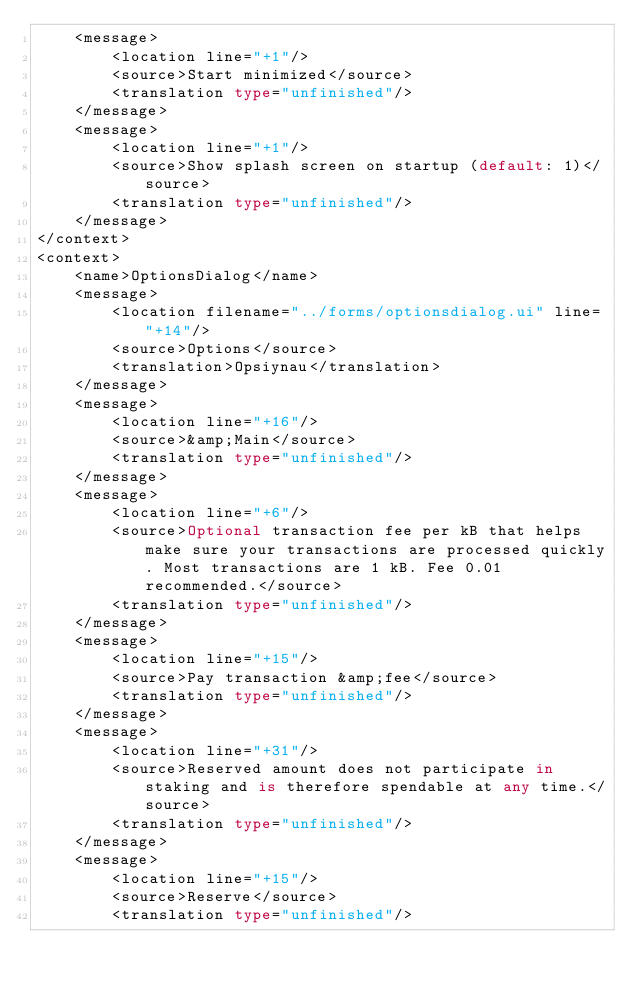Convert code to text. <code><loc_0><loc_0><loc_500><loc_500><_TypeScript_>    <message>
        <location line="+1"/>
        <source>Start minimized</source>
        <translation type="unfinished"/>
    </message>
    <message>
        <location line="+1"/>
        <source>Show splash screen on startup (default: 1)</source>
        <translation type="unfinished"/>
    </message>
</context>
<context>
    <name>OptionsDialog</name>
    <message>
        <location filename="../forms/optionsdialog.ui" line="+14"/>
        <source>Options</source>
        <translation>Opsiynau</translation>
    </message>
    <message>
        <location line="+16"/>
        <source>&amp;Main</source>
        <translation type="unfinished"/>
    </message>
    <message>
        <location line="+6"/>
        <source>Optional transaction fee per kB that helps make sure your transactions are processed quickly. Most transactions are 1 kB. Fee 0.01 recommended.</source>
        <translation type="unfinished"/>
    </message>
    <message>
        <location line="+15"/>
        <source>Pay transaction &amp;fee</source>
        <translation type="unfinished"/>
    </message>
    <message>
        <location line="+31"/>
        <source>Reserved amount does not participate in staking and is therefore spendable at any time.</source>
        <translation type="unfinished"/>
    </message>
    <message>
        <location line="+15"/>
        <source>Reserve</source>
        <translation type="unfinished"/></code> 